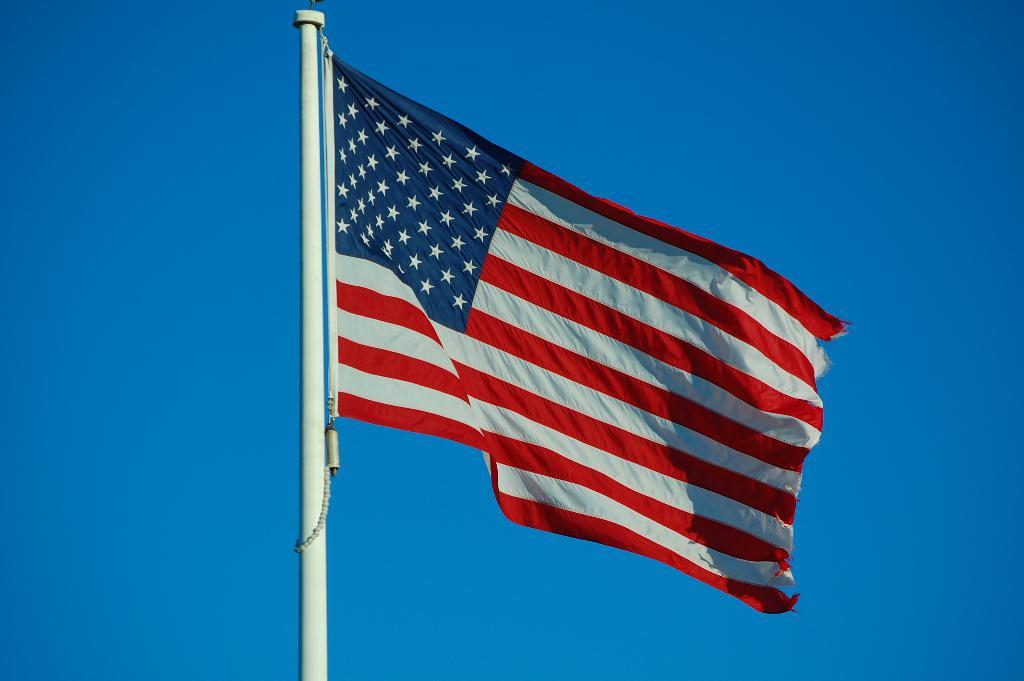What flag is visible in the image? There is a United States of America flag in the image. How is the flag displayed in the image? The flag is on a pole. What can be seen in the background of the image? There is sky visible in the background of the image. What type of beef is being served at the event in the image? There is no event or beef present in the image; it only features a United States of America flag on a pole with sky visible in the background. 